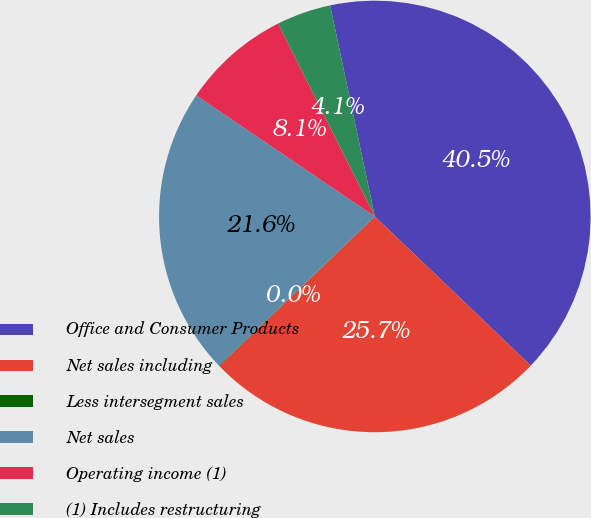Convert chart. <chart><loc_0><loc_0><loc_500><loc_500><pie_chart><fcel>Office and Consumer Products<fcel>Net sales including<fcel>Less intersegment sales<fcel>Net sales<fcel>Operating income (1)<fcel>(1) Includes restructuring<nl><fcel>40.47%<fcel>25.67%<fcel>0.04%<fcel>21.63%<fcel>8.12%<fcel>4.08%<nl></chart> 